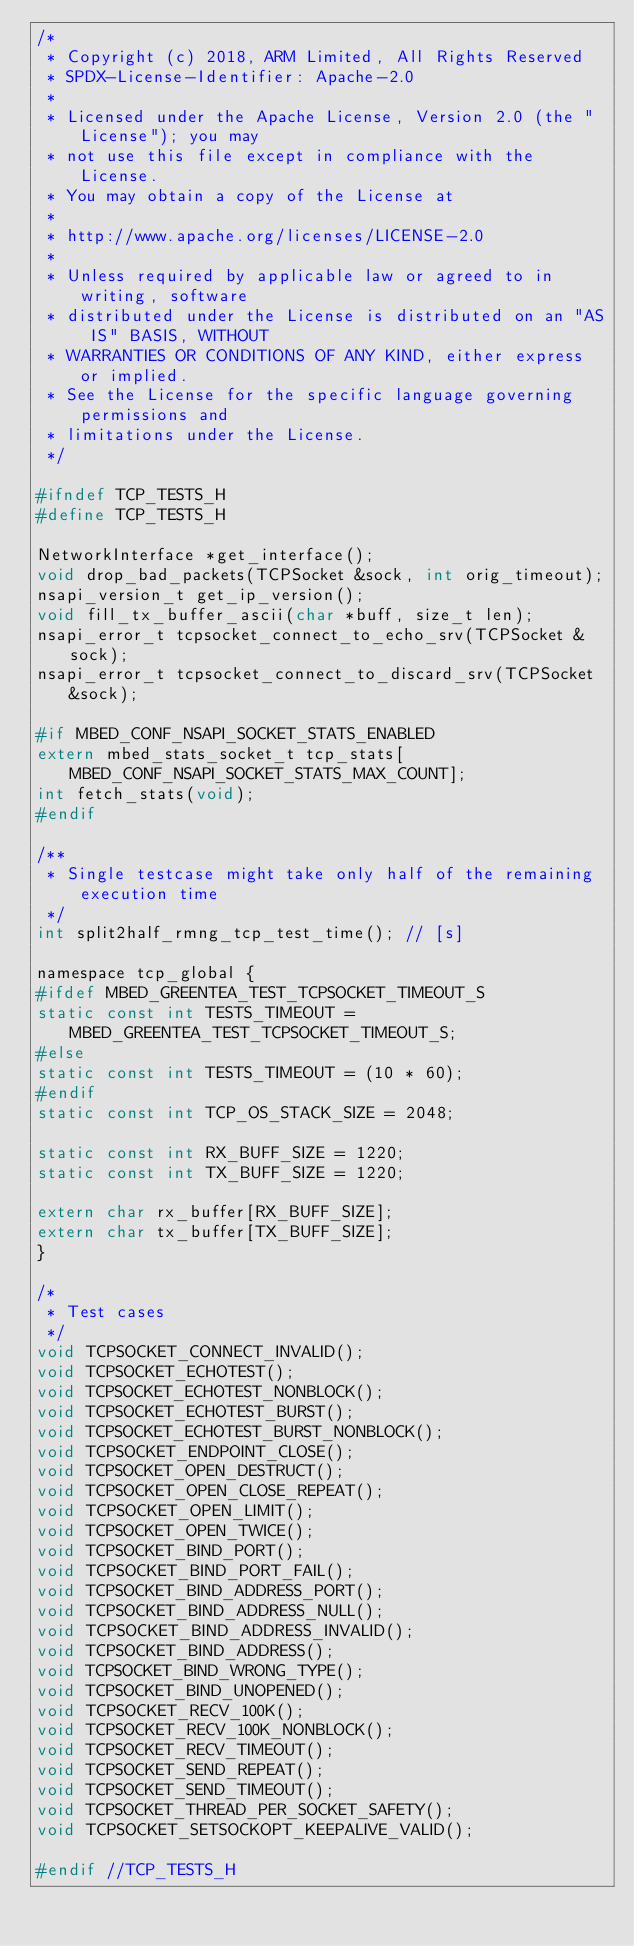<code> <loc_0><loc_0><loc_500><loc_500><_C_>/*
 * Copyright (c) 2018, ARM Limited, All Rights Reserved
 * SPDX-License-Identifier: Apache-2.0
 *
 * Licensed under the Apache License, Version 2.0 (the "License"); you may
 * not use this file except in compliance with the License.
 * You may obtain a copy of the License at
 *
 * http://www.apache.org/licenses/LICENSE-2.0
 *
 * Unless required by applicable law or agreed to in writing, software
 * distributed under the License is distributed on an "AS IS" BASIS, WITHOUT
 * WARRANTIES OR CONDITIONS OF ANY KIND, either express or implied.
 * See the License for the specific language governing permissions and
 * limitations under the License.
 */

#ifndef TCP_TESTS_H
#define TCP_TESTS_H

NetworkInterface *get_interface();
void drop_bad_packets(TCPSocket &sock, int orig_timeout);
nsapi_version_t get_ip_version();
void fill_tx_buffer_ascii(char *buff, size_t len);
nsapi_error_t tcpsocket_connect_to_echo_srv(TCPSocket &sock);
nsapi_error_t tcpsocket_connect_to_discard_srv(TCPSocket &sock);

#if MBED_CONF_NSAPI_SOCKET_STATS_ENABLED
extern mbed_stats_socket_t tcp_stats[MBED_CONF_NSAPI_SOCKET_STATS_MAX_COUNT];
int fetch_stats(void);
#endif

/**
 * Single testcase might take only half of the remaining execution time
 */
int split2half_rmng_tcp_test_time(); // [s]

namespace tcp_global {
#ifdef MBED_GREENTEA_TEST_TCPSOCKET_TIMEOUT_S
static const int TESTS_TIMEOUT = MBED_GREENTEA_TEST_TCPSOCKET_TIMEOUT_S;
#else
static const int TESTS_TIMEOUT = (10 * 60);
#endif
static const int TCP_OS_STACK_SIZE = 2048;

static const int RX_BUFF_SIZE = 1220;
static const int TX_BUFF_SIZE = 1220;

extern char rx_buffer[RX_BUFF_SIZE];
extern char tx_buffer[TX_BUFF_SIZE];
}

/*
 * Test cases
 */
void TCPSOCKET_CONNECT_INVALID();
void TCPSOCKET_ECHOTEST();
void TCPSOCKET_ECHOTEST_NONBLOCK();
void TCPSOCKET_ECHOTEST_BURST();
void TCPSOCKET_ECHOTEST_BURST_NONBLOCK();
void TCPSOCKET_ENDPOINT_CLOSE();
void TCPSOCKET_OPEN_DESTRUCT();
void TCPSOCKET_OPEN_CLOSE_REPEAT();
void TCPSOCKET_OPEN_LIMIT();
void TCPSOCKET_OPEN_TWICE();
void TCPSOCKET_BIND_PORT();
void TCPSOCKET_BIND_PORT_FAIL();
void TCPSOCKET_BIND_ADDRESS_PORT();
void TCPSOCKET_BIND_ADDRESS_NULL();
void TCPSOCKET_BIND_ADDRESS_INVALID();
void TCPSOCKET_BIND_ADDRESS();
void TCPSOCKET_BIND_WRONG_TYPE();
void TCPSOCKET_BIND_UNOPENED();
void TCPSOCKET_RECV_100K();
void TCPSOCKET_RECV_100K_NONBLOCK();
void TCPSOCKET_RECV_TIMEOUT();
void TCPSOCKET_SEND_REPEAT();
void TCPSOCKET_SEND_TIMEOUT();
void TCPSOCKET_THREAD_PER_SOCKET_SAFETY();
void TCPSOCKET_SETSOCKOPT_KEEPALIVE_VALID();

#endif //TCP_TESTS_H
</code> 